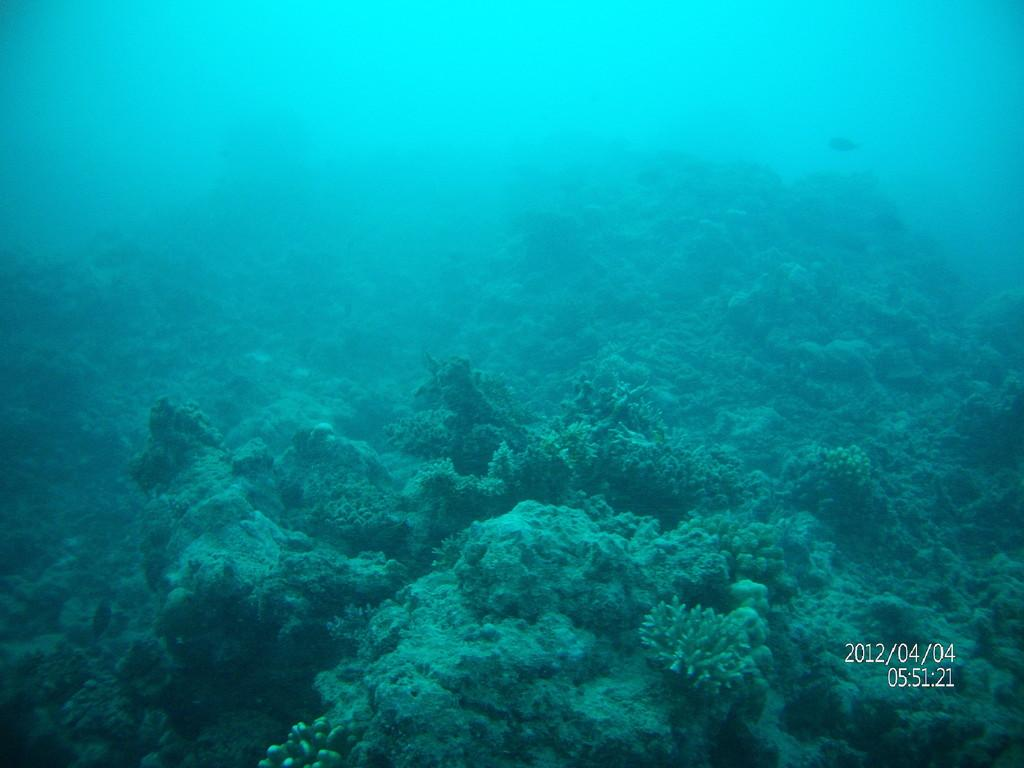What is the setting of the image? The image is taken underwater. What type of objects can be seen in the image? There are objects in the image that resemble corals. Is there any additional information or branding on the image? Yes, the image has a watermark. What is the color of the moon in the image? There is no moon present in the image, as it is taken underwater. 